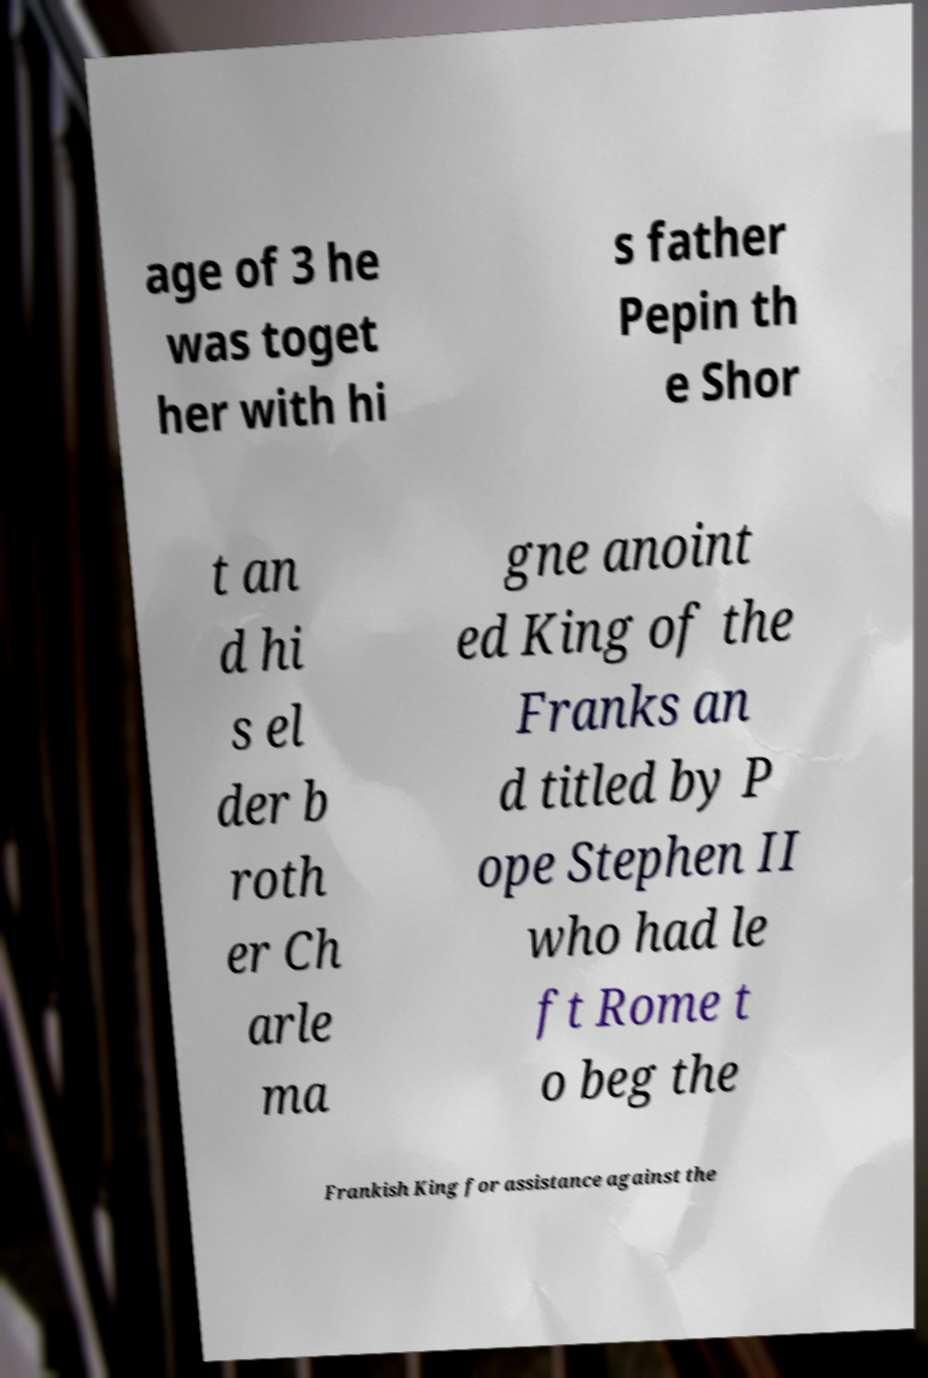Please identify and transcribe the text found in this image. age of 3 he was toget her with hi s father Pepin th e Shor t an d hi s el der b roth er Ch arle ma gne anoint ed King of the Franks an d titled by P ope Stephen II who had le ft Rome t o beg the Frankish King for assistance against the 